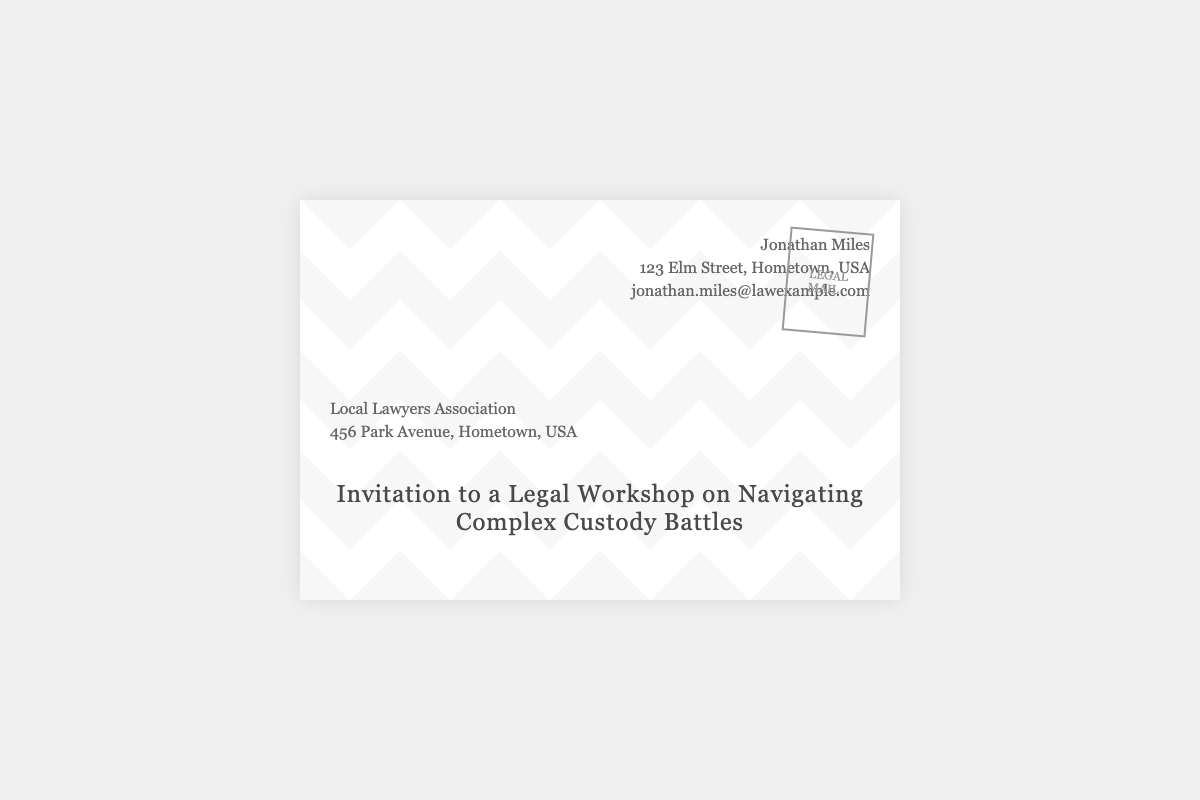What is the name of the sender? The sender's name is indicated at the top of the envelope.
Answer: Jonathan Miles What is the email address of the sender? The email address is listed beneath the sender's name.
Answer: jonathan.miles@lawexample.com Where is the recipient located? The recipient's address is shown below their name.
Answer: 456 Park Avenue, Hometown, USA What is the title of the workshop? The title is prominently displayed in the center of the envelope.
Answer: Navigating Complex Custody Battles What type of mail is this? The type of mail is indicated in the stamp on the envelope.
Answer: LEGAL MAIL How many street addresses are listed in the document? There are two addresses shown: one for the sender and one for the recipient.
Answer: 2 What is the company or association of the recipient? The association's name is mentioned above the recipient's address.
Answer: Local Lawyers Association What can be inferred about the purpose of this envelope? The envelope serves as an invitation for a legal workshop, which suggests a professional development opportunity for lawyers.
Answer: Invitation to a Legal Workshop 